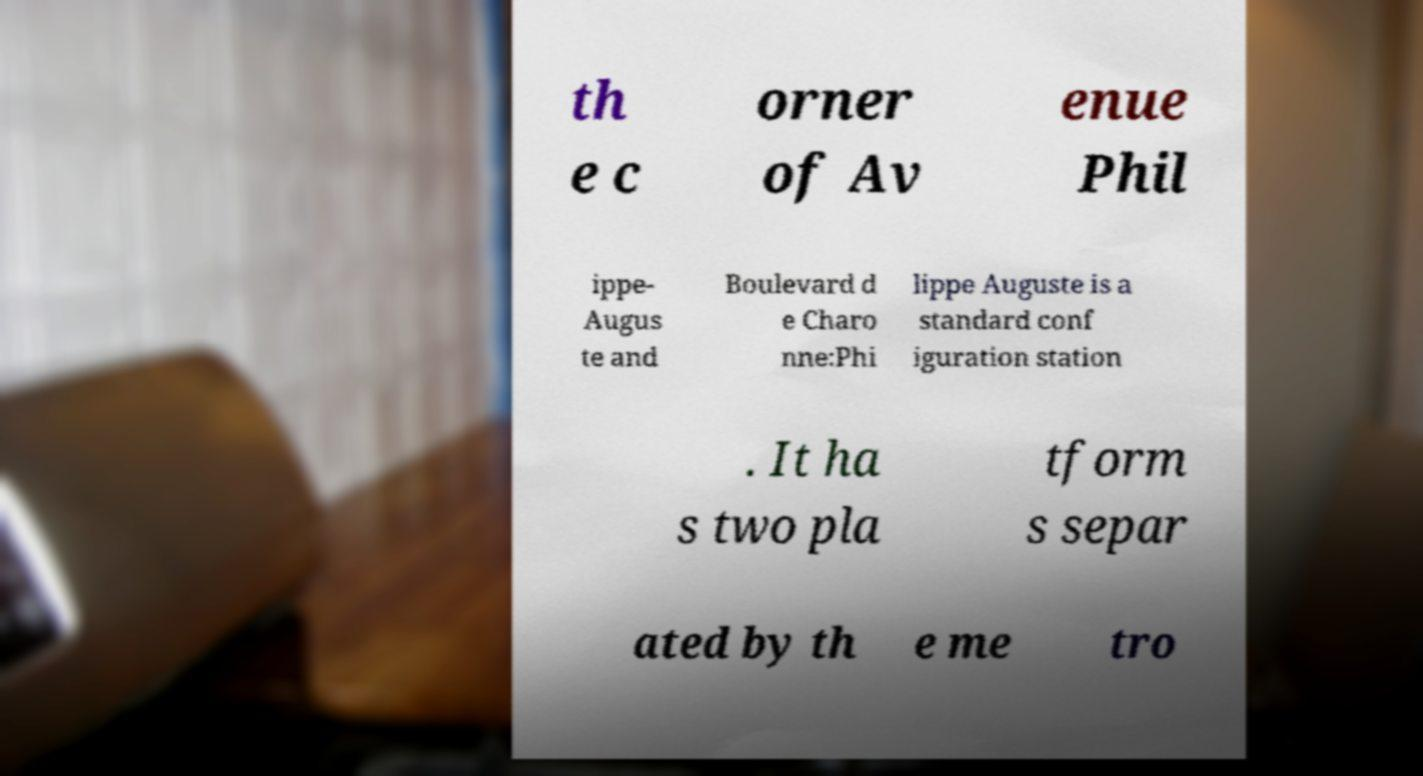Please identify and transcribe the text found in this image. th e c orner of Av enue Phil ippe- Augus te and Boulevard d e Charo nne:Phi lippe Auguste is a standard conf iguration station . It ha s two pla tform s separ ated by th e me tro 